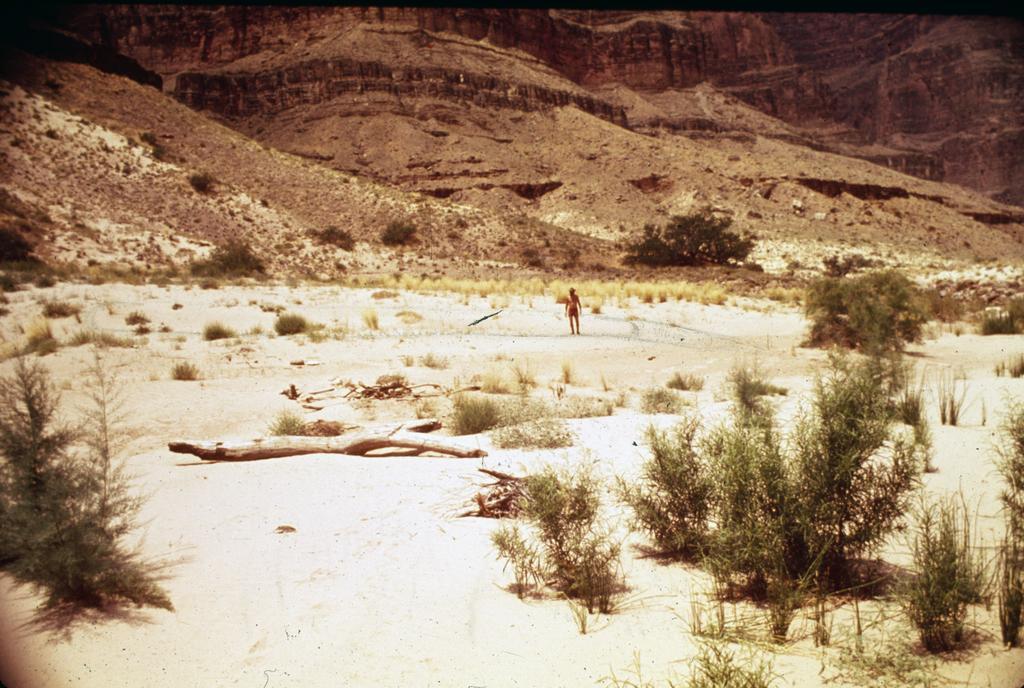Describe this image in one or two sentences. In the image there are plants and grass on a land and there is a person standing on the land, in the background there are mountains. 